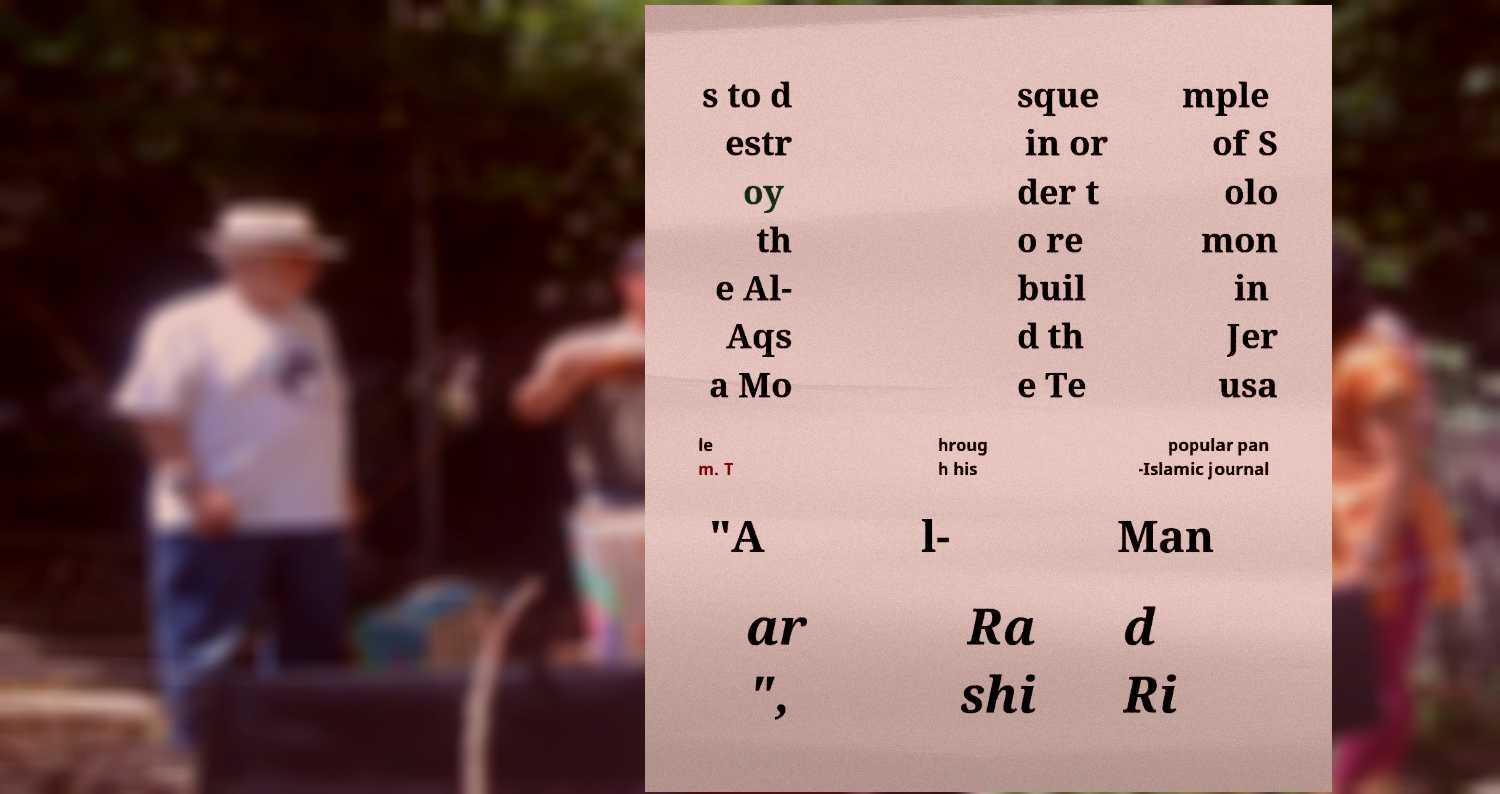Could you assist in decoding the text presented in this image and type it out clearly? s to d estr oy th e Al- Aqs a Mo sque in or der t o re buil d th e Te mple of S olo mon in Jer usa le m. T hroug h his popular pan -Islamic journal "A l- Man ar ", Ra shi d Ri 